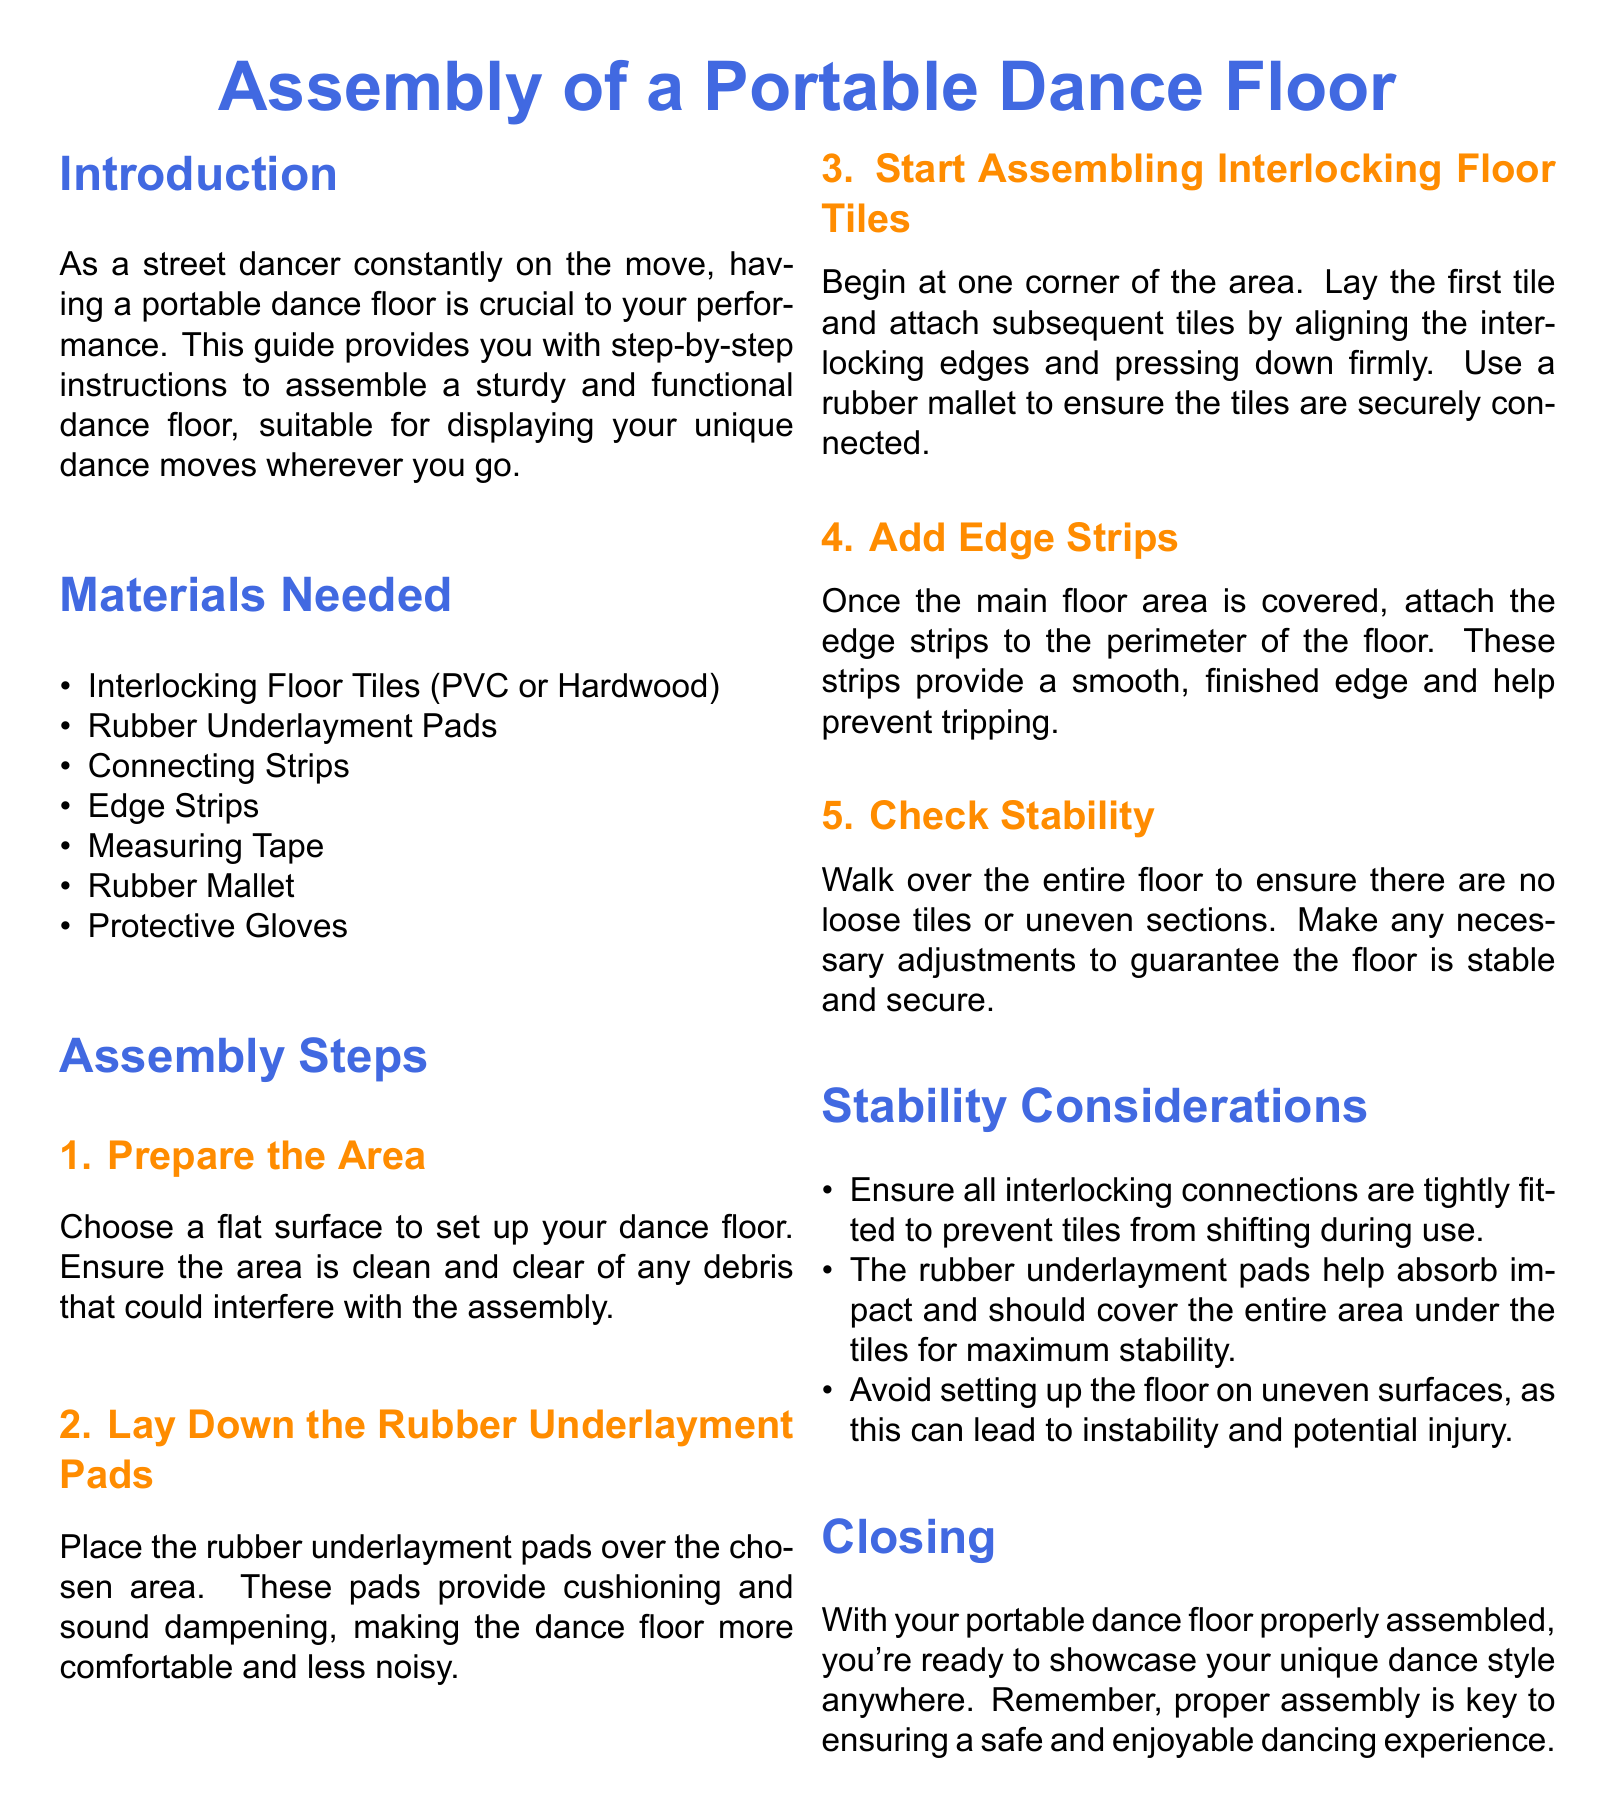What is the first step in assembling the dance floor? The first step involves preparing the area by choosing a flat surface and ensuring it is clean.
Answer: Prepare the Area How many materials are listed in the document? The document lists a total of seven materials needed for assembly.
Answer: Seven What type of pads should be used under the dance floor tiles? The document specifies using rubber underlayment pads for cushioning and sound dampening.
Answer: Rubber Underlayment Pads What tool is recommended for securely connecting the interlocking tiles? A rubber mallet is recommended to ensure the tiles are securely connected.
Answer: Rubber Mallet What should be checked for stability after assembly? Stability should be checked by walking over the floor to ensure there are no loose tiles or uneven sections.
Answer: Loose tiles or uneven sections Why is it necessary to avoid setting up the floor on uneven surfaces? Setting up on uneven surfaces can lead to instability and potential injury.
Answer: Instability What is the purpose of the edge strips? Edge strips provide a smooth, finished edge and help prevent tripping.
Answer: Prevent tripping What color is used for the section titles in the document? The title color used in the document is dance blue.
Answer: Dance blue 